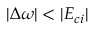<formula> <loc_0><loc_0><loc_500><loc_500>| \Delta \omega | < | E _ { c i } |</formula> 